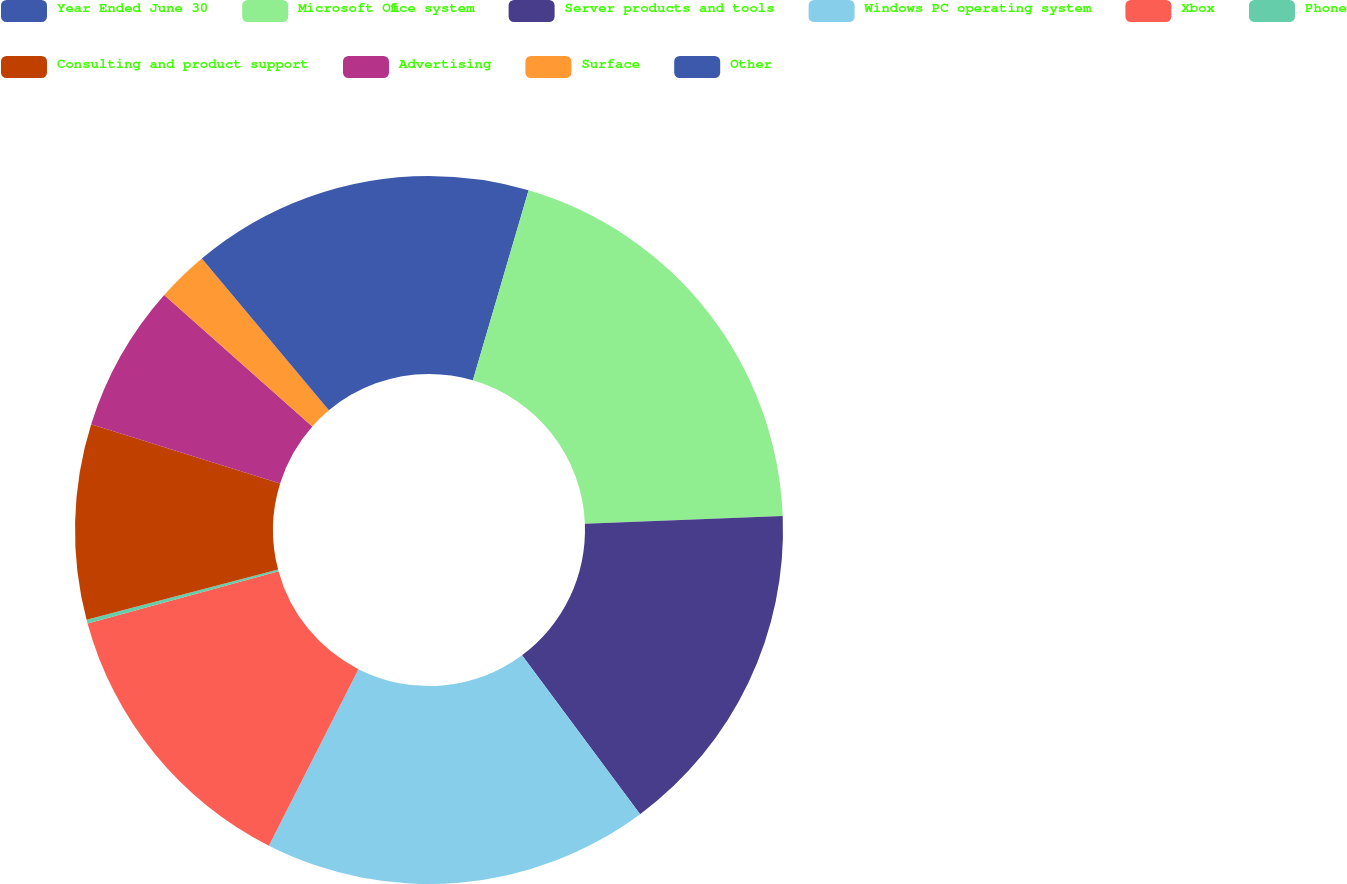Convert chart. <chart><loc_0><loc_0><loc_500><loc_500><pie_chart><fcel>Year Ended June 30<fcel>Microsoft Office system<fcel>Server products and tools<fcel>Windows PC operating system<fcel>Xbox<fcel>Phone<fcel>Consulting and product support<fcel>Advertising<fcel>Surface<fcel>Other<nl><fcel>4.54%<fcel>19.83%<fcel>15.46%<fcel>17.64%<fcel>13.28%<fcel>0.17%<fcel>8.91%<fcel>6.72%<fcel>2.36%<fcel>11.09%<nl></chart> 